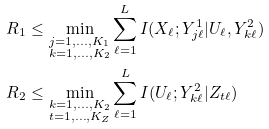<formula> <loc_0><loc_0><loc_500><loc_500>R _ { 1 } & \leq \min _ { \substack { j = 1 , \dots , K _ { 1 } \\ k = 1 , \dots , K _ { 2 } } } \sum _ { \ell = 1 } ^ { L } I ( X _ { \ell } ; Y _ { j \ell } ^ { 1 } | U _ { \ell } , Y _ { k \ell } ^ { 2 } ) \\ R _ { 2 } & \leq \min _ { \substack { k = 1 , \dots , K _ { 2 } \\ t = 1 , \dots , K _ { Z } } } \sum _ { \ell = 1 } ^ { L } I ( U _ { \ell } ; Y _ { k \ell } ^ { 2 } | Z _ { t \ell } )</formula> 